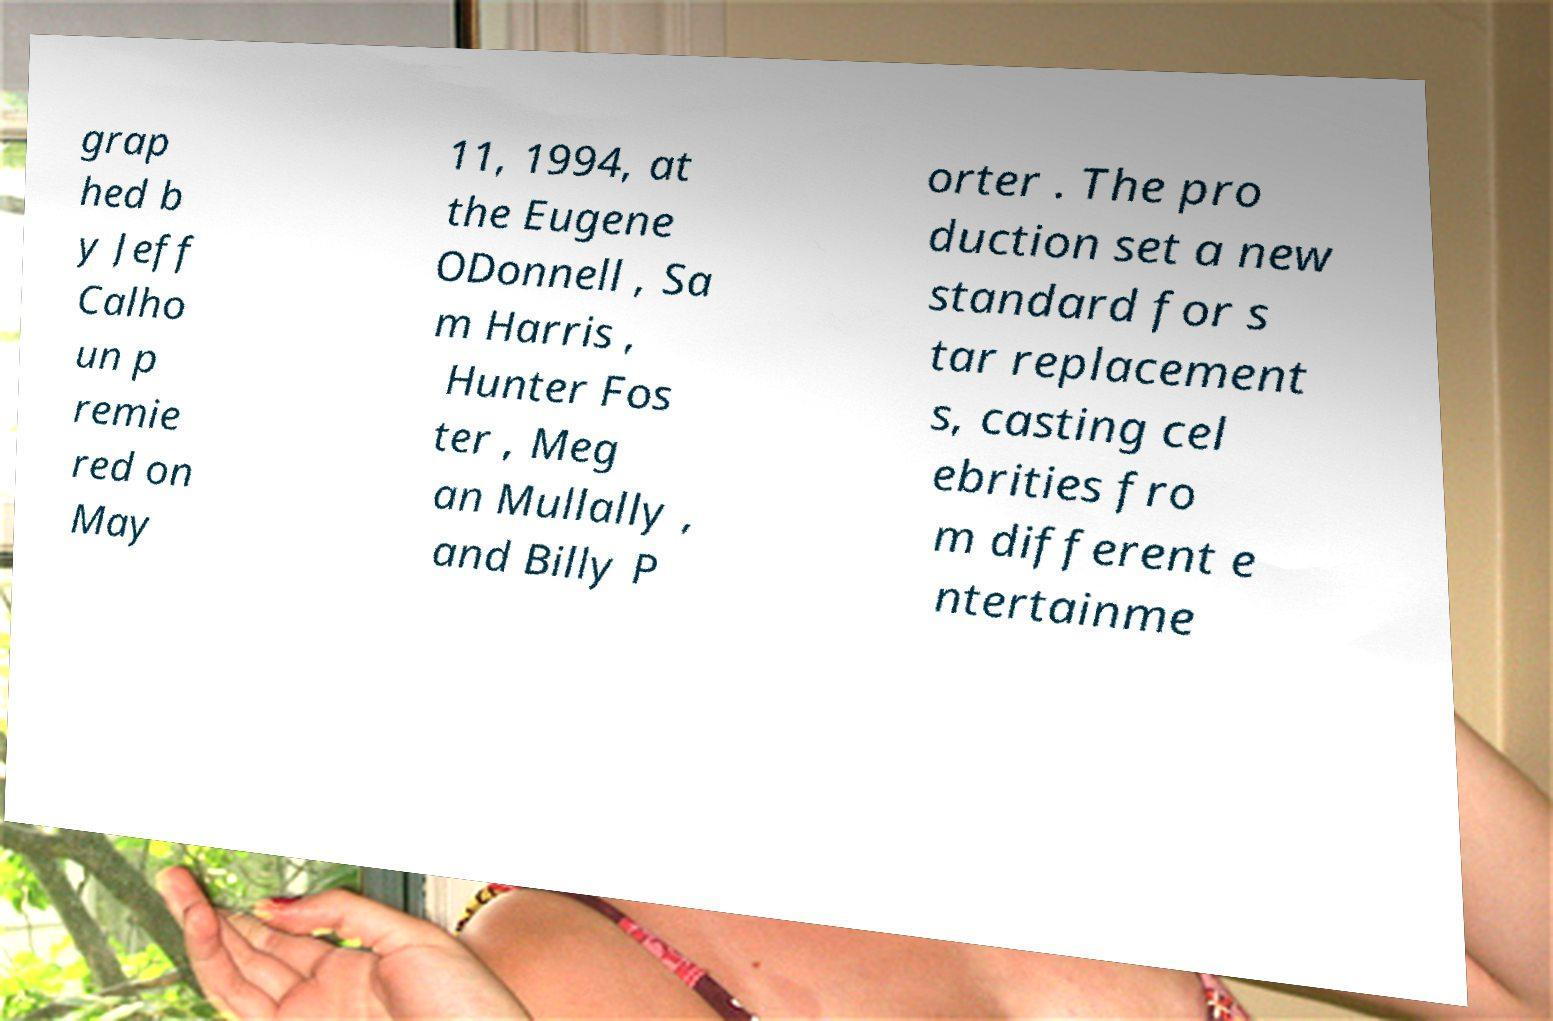Please read and relay the text visible in this image. What does it say? grap hed b y Jeff Calho un p remie red on May 11, 1994, at the Eugene ODonnell , Sa m Harris , Hunter Fos ter , Meg an Mullally , and Billy P orter . The pro duction set a new standard for s tar replacement s, casting cel ebrities fro m different e ntertainme 